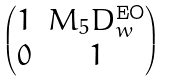<formula> <loc_0><loc_0><loc_500><loc_500>\begin{pmatrix} 1 & M _ { 5 } D _ { w } ^ { \text {EO} } \\ 0 & 1 \end{pmatrix}</formula> 